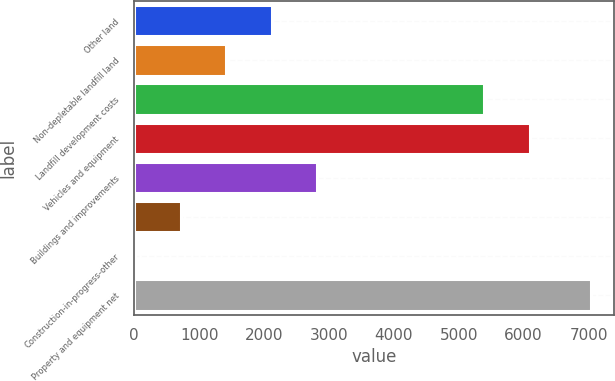Convert chart. <chart><loc_0><loc_0><loc_500><loc_500><bar_chart><fcel>Other land<fcel>Non-depletable landfill land<fcel>Landfill development costs<fcel>Vehicles and equipment<fcel>Buildings and improvements<fcel>Unnamed: 5<fcel>Construction-in-progress-other<fcel>Property and equipment net<nl><fcel>2120.35<fcel>1418<fcel>5392.7<fcel>6095.05<fcel>2822.7<fcel>715.65<fcel>13.3<fcel>7036.8<nl></chart> 